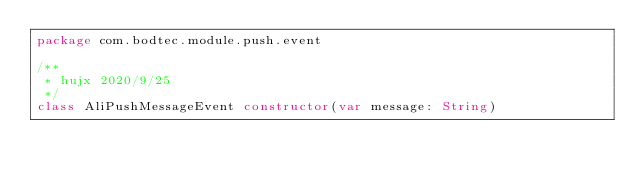<code> <loc_0><loc_0><loc_500><loc_500><_Kotlin_>package com.bodtec.module.push.event

/**
 * hujx 2020/9/25
 */
class AliPushMessageEvent constructor(var message: String)</code> 